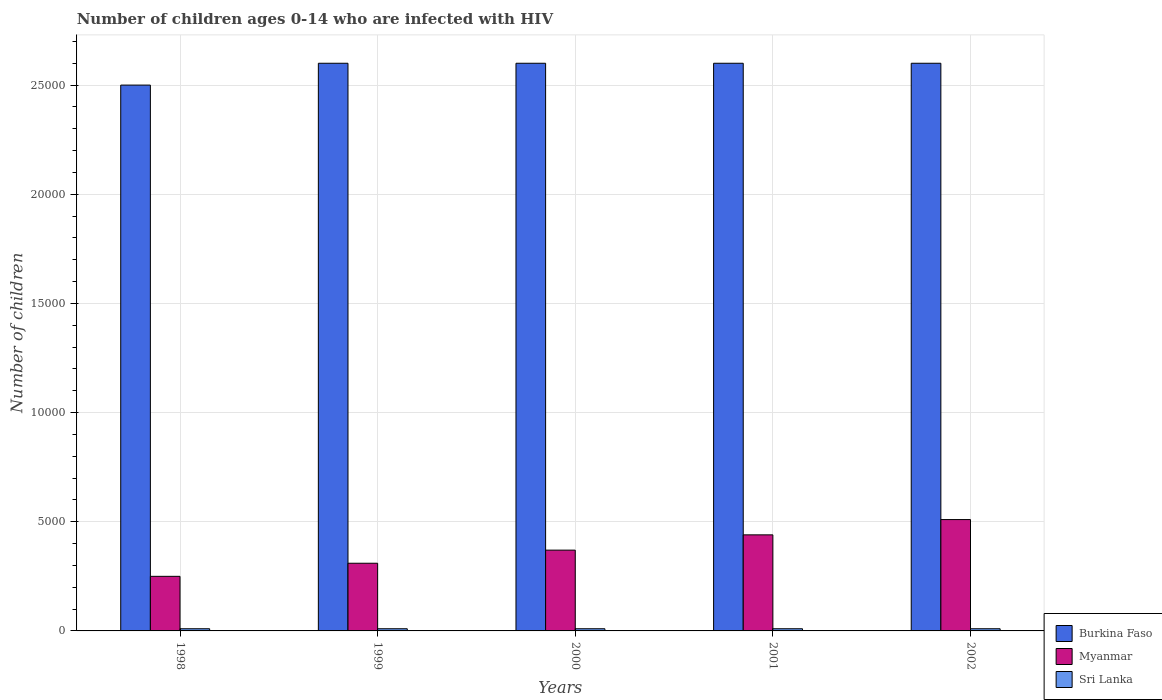How many different coloured bars are there?
Provide a succinct answer. 3. How many groups of bars are there?
Provide a succinct answer. 5. How many bars are there on the 2nd tick from the right?
Ensure brevity in your answer.  3. What is the label of the 5th group of bars from the left?
Provide a succinct answer. 2002. In how many cases, is the number of bars for a given year not equal to the number of legend labels?
Keep it short and to the point. 0. What is the number of HIV infected children in Sri Lanka in 2000?
Keep it short and to the point. 100. Across all years, what is the maximum number of HIV infected children in Sri Lanka?
Offer a very short reply. 100. Across all years, what is the minimum number of HIV infected children in Sri Lanka?
Offer a very short reply. 100. In which year was the number of HIV infected children in Burkina Faso maximum?
Your response must be concise. 1999. In which year was the number of HIV infected children in Sri Lanka minimum?
Provide a short and direct response. 1998. What is the total number of HIV infected children in Burkina Faso in the graph?
Your answer should be compact. 1.29e+05. What is the difference between the number of HIV infected children in Burkina Faso in 2000 and the number of HIV infected children in Sri Lanka in 1999?
Make the answer very short. 2.59e+04. What is the average number of HIV infected children in Sri Lanka per year?
Provide a succinct answer. 100. In the year 1998, what is the difference between the number of HIV infected children in Sri Lanka and number of HIV infected children in Myanmar?
Ensure brevity in your answer.  -2400. In how many years, is the number of HIV infected children in Burkina Faso greater than 21000?
Your response must be concise. 5. What is the ratio of the number of HIV infected children in Burkina Faso in 1999 to that in 2000?
Ensure brevity in your answer.  1. What is the difference between the highest and the second highest number of HIV infected children in Sri Lanka?
Your response must be concise. 0. What is the difference between the highest and the lowest number of HIV infected children in Sri Lanka?
Offer a very short reply. 0. In how many years, is the number of HIV infected children in Burkina Faso greater than the average number of HIV infected children in Burkina Faso taken over all years?
Keep it short and to the point. 4. Is the sum of the number of HIV infected children in Burkina Faso in 2001 and 2002 greater than the maximum number of HIV infected children in Sri Lanka across all years?
Make the answer very short. Yes. What does the 1st bar from the left in 2000 represents?
Give a very brief answer. Burkina Faso. What does the 2nd bar from the right in 2001 represents?
Provide a short and direct response. Myanmar. Are all the bars in the graph horizontal?
Your answer should be compact. No. What is the difference between two consecutive major ticks on the Y-axis?
Your answer should be very brief. 5000. Are the values on the major ticks of Y-axis written in scientific E-notation?
Your answer should be very brief. No. Does the graph contain any zero values?
Give a very brief answer. No. Where does the legend appear in the graph?
Your answer should be compact. Bottom right. What is the title of the graph?
Provide a short and direct response. Number of children ages 0-14 who are infected with HIV. Does "Fiji" appear as one of the legend labels in the graph?
Your response must be concise. No. What is the label or title of the X-axis?
Offer a very short reply. Years. What is the label or title of the Y-axis?
Keep it short and to the point. Number of children. What is the Number of children in Burkina Faso in 1998?
Make the answer very short. 2.50e+04. What is the Number of children of Myanmar in 1998?
Keep it short and to the point. 2500. What is the Number of children in Sri Lanka in 1998?
Your response must be concise. 100. What is the Number of children in Burkina Faso in 1999?
Make the answer very short. 2.60e+04. What is the Number of children in Myanmar in 1999?
Ensure brevity in your answer.  3100. What is the Number of children in Sri Lanka in 1999?
Your response must be concise. 100. What is the Number of children of Burkina Faso in 2000?
Provide a short and direct response. 2.60e+04. What is the Number of children of Myanmar in 2000?
Provide a short and direct response. 3700. What is the Number of children in Sri Lanka in 2000?
Ensure brevity in your answer.  100. What is the Number of children of Burkina Faso in 2001?
Ensure brevity in your answer.  2.60e+04. What is the Number of children in Myanmar in 2001?
Your response must be concise. 4400. What is the Number of children of Sri Lanka in 2001?
Your answer should be compact. 100. What is the Number of children of Burkina Faso in 2002?
Keep it short and to the point. 2.60e+04. What is the Number of children of Myanmar in 2002?
Offer a terse response. 5100. What is the Number of children of Sri Lanka in 2002?
Offer a very short reply. 100. Across all years, what is the maximum Number of children of Burkina Faso?
Your answer should be compact. 2.60e+04. Across all years, what is the maximum Number of children of Myanmar?
Ensure brevity in your answer.  5100. Across all years, what is the minimum Number of children in Burkina Faso?
Your answer should be compact. 2.50e+04. Across all years, what is the minimum Number of children in Myanmar?
Provide a succinct answer. 2500. What is the total Number of children of Burkina Faso in the graph?
Keep it short and to the point. 1.29e+05. What is the total Number of children in Myanmar in the graph?
Give a very brief answer. 1.88e+04. What is the total Number of children of Sri Lanka in the graph?
Provide a short and direct response. 500. What is the difference between the Number of children of Burkina Faso in 1998 and that in 1999?
Give a very brief answer. -1000. What is the difference between the Number of children of Myanmar in 1998 and that in 1999?
Make the answer very short. -600. What is the difference between the Number of children in Burkina Faso in 1998 and that in 2000?
Offer a very short reply. -1000. What is the difference between the Number of children of Myanmar in 1998 and that in 2000?
Your response must be concise. -1200. What is the difference between the Number of children of Sri Lanka in 1998 and that in 2000?
Give a very brief answer. 0. What is the difference between the Number of children in Burkina Faso in 1998 and that in 2001?
Make the answer very short. -1000. What is the difference between the Number of children of Myanmar in 1998 and that in 2001?
Your answer should be very brief. -1900. What is the difference between the Number of children of Sri Lanka in 1998 and that in 2001?
Your answer should be very brief. 0. What is the difference between the Number of children of Burkina Faso in 1998 and that in 2002?
Your answer should be compact. -1000. What is the difference between the Number of children of Myanmar in 1998 and that in 2002?
Ensure brevity in your answer.  -2600. What is the difference between the Number of children in Burkina Faso in 1999 and that in 2000?
Provide a succinct answer. 0. What is the difference between the Number of children in Myanmar in 1999 and that in 2000?
Your answer should be compact. -600. What is the difference between the Number of children of Sri Lanka in 1999 and that in 2000?
Offer a very short reply. 0. What is the difference between the Number of children in Burkina Faso in 1999 and that in 2001?
Your answer should be compact. 0. What is the difference between the Number of children in Myanmar in 1999 and that in 2001?
Make the answer very short. -1300. What is the difference between the Number of children of Sri Lanka in 1999 and that in 2001?
Provide a succinct answer. 0. What is the difference between the Number of children of Myanmar in 1999 and that in 2002?
Your response must be concise. -2000. What is the difference between the Number of children in Myanmar in 2000 and that in 2001?
Offer a very short reply. -700. What is the difference between the Number of children in Burkina Faso in 2000 and that in 2002?
Give a very brief answer. 0. What is the difference between the Number of children in Myanmar in 2000 and that in 2002?
Your answer should be very brief. -1400. What is the difference between the Number of children of Sri Lanka in 2000 and that in 2002?
Offer a very short reply. 0. What is the difference between the Number of children in Burkina Faso in 2001 and that in 2002?
Your answer should be compact. 0. What is the difference between the Number of children in Myanmar in 2001 and that in 2002?
Offer a terse response. -700. What is the difference between the Number of children in Sri Lanka in 2001 and that in 2002?
Provide a succinct answer. 0. What is the difference between the Number of children in Burkina Faso in 1998 and the Number of children in Myanmar in 1999?
Your response must be concise. 2.19e+04. What is the difference between the Number of children of Burkina Faso in 1998 and the Number of children of Sri Lanka in 1999?
Make the answer very short. 2.49e+04. What is the difference between the Number of children of Myanmar in 1998 and the Number of children of Sri Lanka in 1999?
Your response must be concise. 2400. What is the difference between the Number of children in Burkina Faso in 1998 and the Number of children in Myanmar in 2000?
Keep it short and to the point. 2.13e+04. What is the difference between the Number of children of Burkina Faso in 1998 and the Number of children of Sri Lanka in 2000?
Ensure brevity in your answer.  2.49e+04. What is the difference between the Number of children in Myanmar in 1998 and the Number of children in Sri Lanka in 2000?
Offer a terse response. 2400. What is the difference between the Number of children in Burkina Faso in 1998 and the Number of children in Myanmar in 2001?
Provide a short and direct response. 2.06e+04. What is the difference between the Number of children of Burkina Faso in 1998 and the Number of children of Sri Lanka in 2001?
Keep it short and to the point. 2.49e+04. What is the difference between the Number of children of Myanmar in 1998 and the Number of children of Sri Lanka in 2001?
Provide a short and direct response. 2400. What is the difference between the Number of children of Burkina Faso in 1998 and the Number of children of Myanmar in 2002?
Your answer should be very brief. 1.99e+04. What is the difference between the Number of children in Burkina Faso in 1998 and the Number of children in Sri Lanka in 2002?
Keep it short and to the point. 2.49e+04. What is the difference between the Number of children in Myanmar in 1998 and the Number of children in Sri Lanka in 2002?
Your answer should be compact. 2400. What is the difference between the Number of children of Burkina Faso in 1999 and the Number of children of Myanmar in 2000?
Ensure brevity in your answer.  2.23e+04. What is the difference between the Number of children of Burkina Faso in 1999 and the Number of children of Sri Lanka in 2000?
Your answer should be compact. 2.59e+04. What is the difference between the Number of children in Myanmar in 1999 and the Number of children in Sri Lanka in 2000?
Keep it short and to the point. 3000. What is the difference between the Number of children of Burkina Faso in 1999 and the Number of children of Myanmar in 2001?
Your response must be concise. 2.16e+04. What is the difference between the Number of children of Burkina Faso in 1999 and the Number of children of Sri Lanka in 2001?
Your answer should be compact. 2.59e+04. What is the difference between the Number of children in Myanmar in 1999 and the Number of children in Sri Lanka in 2001?
Give a very brief answer. 3000. What is the difference between the Number of children in Burkina Faso in 1999 and the Number of children in Myanmar in 2002?
Provide a succinct answer. 2.09e+04. What is the difference between the Number of children in Burkina Faso in 1999 and the Number of children in Sri Lanka in 2002?
Ensure brevity in your answer.  2.59e+04. What is the difference between the Number of children in Myanmar in 1999 and the Number of children in Sri Lanka in 2002?
Offer a very short reply. 3000. What is the difference between the Number of children of Burkina Faso in 2000 and the Number of children of Myanmar in 2001?
Ensure brevity in your answer.  2.16e+04. What is the difference between the Number of children of Burkina Faso in 2000 and the Number of children of Sri Lanka in 2001?
Keep it short and to the point. 2.59e+04. What is the difference between the Number of children in Myanmar in 2000 and the Number of children in Sri Lanka in 2001?
Give a very brief answer. 3600. What is the difference between the Number of children of Burkina Faso in 2000 and the Number of children of Myanmar in 2002?
Your response must be concise. 2.09e+04. What is the difference between the Number of children in Burkina Faso in 2000 and the Number of children in Sri Lanka in 2002?
Offer a terse response. 2.59e+04. What is the difference between the Number of children in Myanmar in 2000 and the Number of children in Sri Lanka in 2002?
Offer a very short reply. 3600. What is the difference between the Number of children of Burkina Faso in 2001 and the Number of children of Myanmar in 2002?
Ensure brevity in your answer.  2.09e+04. What is the difference between the Number of children of Burkina Faso in 2001 and the Number of children of Sri Lanka in 2002?
Provide a succinct answer. 2.59e+04. What is the difference between the Number of children in Myanmar in 2001 and the Number of children in Sri Lanka in 2002?
Offer a very short reply. 4300. What is the average Number of children in Burkina Faso per year?
Offer a terse response. 2.58e+04. What is the average Number of children in Myanmar per year?
Keep it short and to the point. 3760. In the year 1998, what is the difference between the Number of children of Burkina Faso and Number of children of Myanmar?
Make the answer very short. 2.25e+04. In the year 1998, what is the difference between the Number of children of Burkina Faso and Number of children of Sri Lanka?
Provide a short and direct response. 2.49e+04. In the year 1998, what is the difference between the Number of children in Myanmar and Number of children in Sri Lanka?
Provide a succinct answer. 2400. In the year 1999, what is the difference between the Number of children of Burkina Faso and Number of children of Myanmar?
Provide a short and direct response. 2.29e+04. In the year 1999, what is the difference between the Number of children in Burkina Faso and Number of children in Sri Lanka?
Provide a short and direct response. 2.59e+04. In the year 1999, what is the difference between the Number of children of Myanmar and Number of children of Sri Lanka?
Keep it short and to the point. 3000. In the year 2000, what is the difference between the Number of children of Burkina Faso and Number of children of Myanmar?
Ensure brevity in your answer.  2.23e+04. In the year 2000, what is the difference between the Number of children in Burkina Faso and Number of children in Sri Lanka?
Offer a terse response. 2.59e+04. In the year 2000, what is the difference between the Number of children in Myanmar and Number of children in Sri Lanka?
Make the answer very short. 3600. In the year 2001, what is the difference between the Number of children of Burkina Faso and Number of children of Myanmar?
Provide a succinct answer. 2.16e+04. In the year 2001, what is the difference between the Number of children in Burkina Faso and Number of children in Sri Lanka?
Ensure brevity in your answer.  2.59e+04. In the year 2001, what is the difference between the Number of children in Myanmar and Number of children in Sri Lanka?
Keep it short and to the point. 4300. In the year 2002, what is the difference between the Number of children in Burkina Faso and Number of children in Myanmar?
Offer a terse response. 2.09e+04. In the year 2002, what is the difference between the Number of children of Burkina Faso and Number of children of Sri Lanka?
Provide a short and direct response. 2.59e+04. What is the ratio of the Number of children in Burkina Faso in 1998 to that in 1999?
Give a very brief answer. 0.96. What is the ratio of the Number of children of Myanmar in 1998 to that in 1999?
Your answer should be very brief. 0.81. What is the ratio of the Number of children of Burkina Faso in 1998 to that in 2000?
Your answer should be very brief. 0.96. What is the ratio of the Number of children in Myanmar in 1998 to that in 2000?
Offer a terse response. 0.68. What is the ratio of the Number of children in Burkina Faso in 1998 to that in 2001?
Provide a short and direct response. 0.96. What is the ratio of the Number of children in Myanmar in 1998 to that in 2001?
Make the answer very short. 0.57. What is the ratio of the Number of children of Sri Lanka in 1998 to that in 2001?
Keep it short and to the point. 1. What is the ratio of the Number of children in Burkina Faso in 1998 to that in 2002?
Keep it short and to the point. 0.96. What is the ratio of the Number of children in Myanmar in 1998 to that in 2002?
Offer a terse response. 0.49. What is the ratio of the Number of children of Sri Lanka in 1998 to that in 2002?
Your response must be concise. 1. What is the ratio of the Number of children in Myanmar in 1999 to that in 2000?
Provide a succinct answer. 0.84. What is the ratio of the Number of children of Sri Lanka in 1999 to that in 2000?
Make the answer very short. 1. What is the ratio of the Number of children of Myanmar in 1999 to that in 2001?
Your answer should be compact. 0.7. What is the ratio of the Number of children of Myanmar in 1999 to that in 2002?
Your response must be concise. 0.61. What is the ratio of the Number of children of Burkina Faso in 2000 to that in 2001?
Give a very brief answer. 1. What is the ratio of the Number of children in Myanmar in 2000 to that in 2001?
Offer a very short reply. 0.84. What is the ratio of the Number of children in Myanmar in 2000 to that in 2002?
Ensure brevity in your answer.  0.73. What is the ratio of the Number of children of Myanmar in 2001 to that in 2002?
Offer a very short reply. 0.86. What is the difference between the highest and the second highest Number of children in Myanmar?
Ensure brevity in your answer.  700. What is the difference between the highest and the lowest Number of children in Myanmar?
Offer a terse response. 2600. What is the difference between the highest and the lowest Number of children of Sri Lanka?
Your answer should be very brief. 0. 